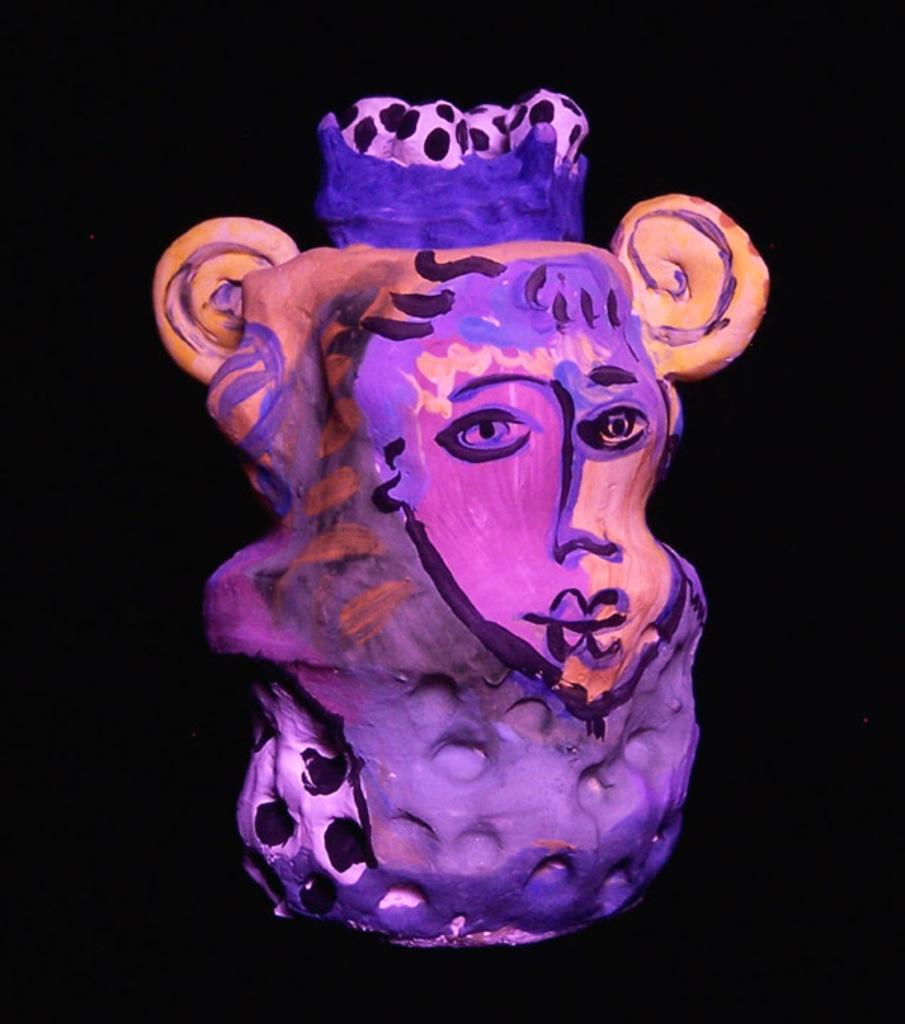What is the main subject in the image? There is a painting in the image. Can you describe the colors used in the painting? The painting has different colors. What is the color of the background in the painting? The background of the painting is dark in color. What type of treatment is being administered to the painting in the image? There is no treatment being administered to the painting in the image; it is simply a static image of the painting. 